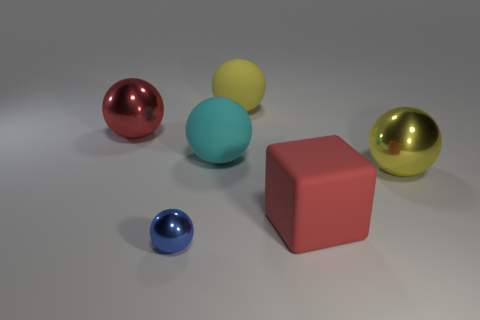Is there a tiny purple sphere? no 